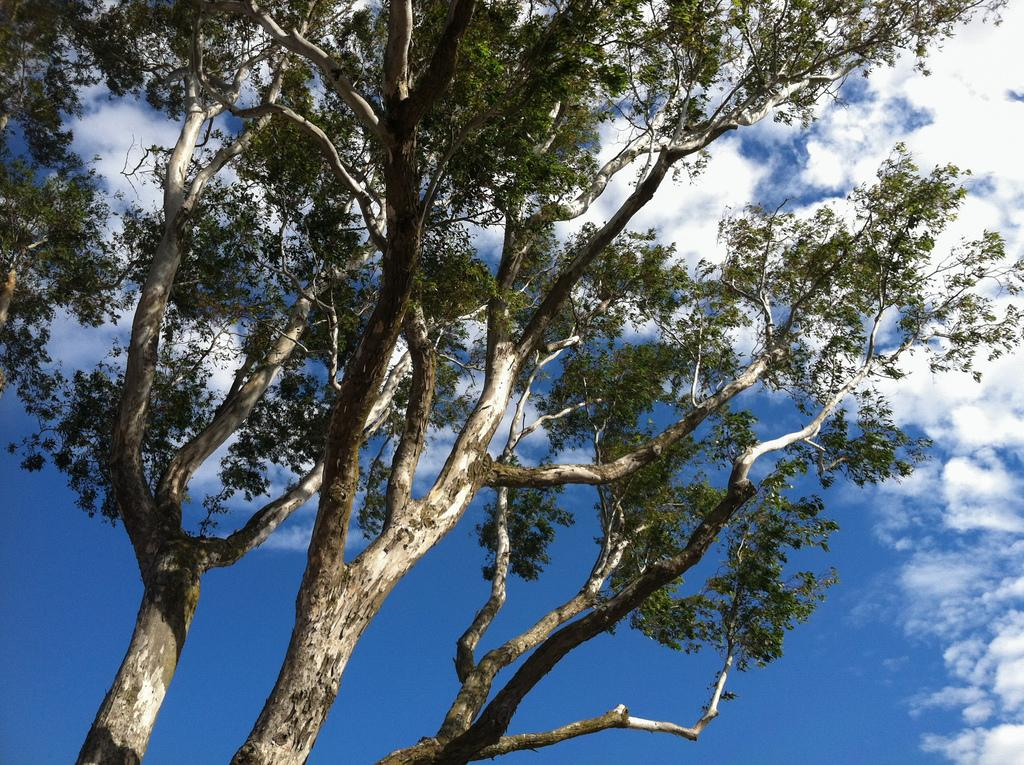What type of plant can be seen in the image? There is a tree in the image. What are the main features of the tree? The tree has branches, stems, and leaves. What can be seen in the background of the image? The sky is visible in the background of the image. What type of soup is being served under the tree in the image? There is no soup present in the image; it features a tree with branches, stems, and leaves, and the sky is visible in the background. 